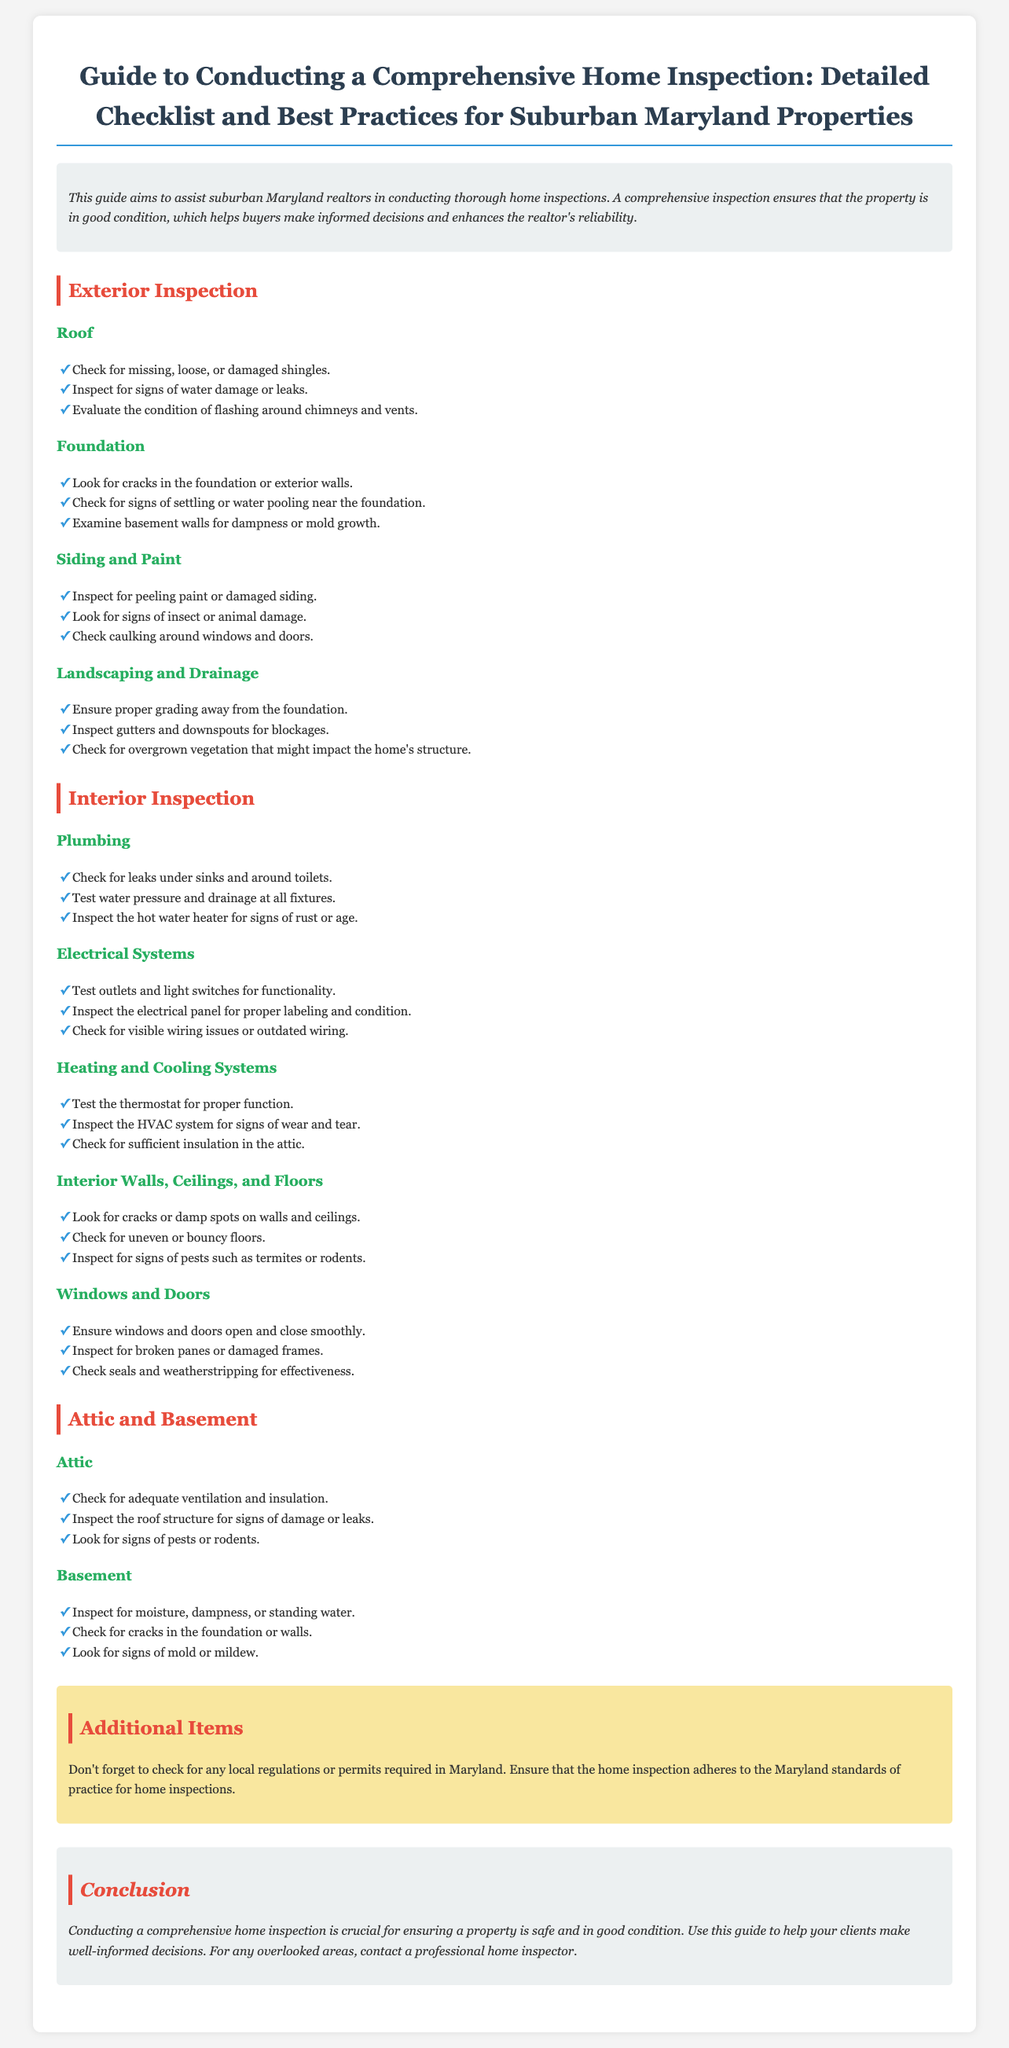What are three exterior inspection areas? The document lists roof, foundation, and siding and paint as areas to inspect.
Answer: roof, foundation, siding and paint What should be checked regarding windows and doors? The document specifies ensuring windows and doors open and close smoothly, inspecting for broken panes or damaged frames, and checking seals.
Answer: open and close smoothly, broken panes or damaged frames, seals What is the focus of the additional items section? It emphasizes checking for local regulations or permits and adhering to Maryland standards of practice for home inspections.
Answer: local regulations or permits What should you inspect for in the attic? Adequate ventilation and insulation are key inspection points in the attic as per the document.
Answer: adequate ventilation and insulation What is the conclusion about home inspections? The document conveys that conducting a comprehensive home inspection is crucial for property safety and conditions.
Answer: crucial for property safety and conditions 